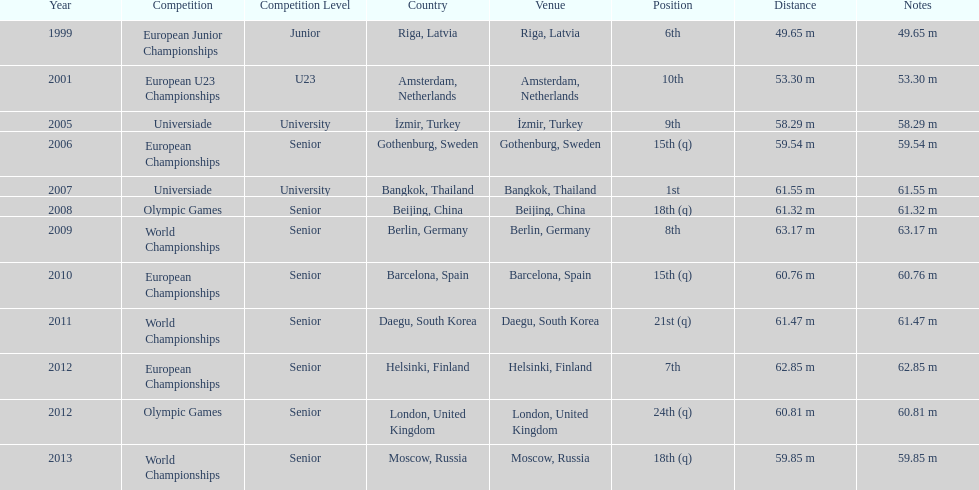Which was the most recent event he competed in before the 2012 olympic games? European Championships. 